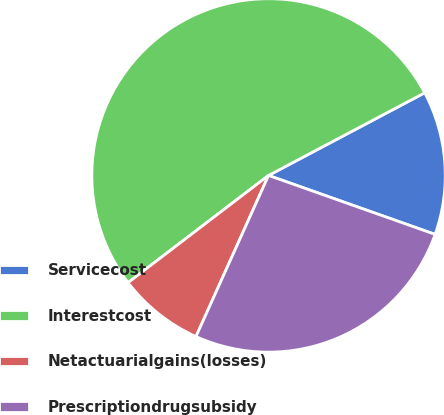Convert chart to OTSL. <chart><loc_0><loc_0><loc_500><loc_500><pie_chart><fcel>Servicecost<fcel>Interestcost<fcel>Netactuarialgains(losses)<fcel>Prescriptiondrugsubsidy<nl><fcel>13.16%<fcel>52.63%<fcel>7.89%<fcel>26.32%<nl></chart> 